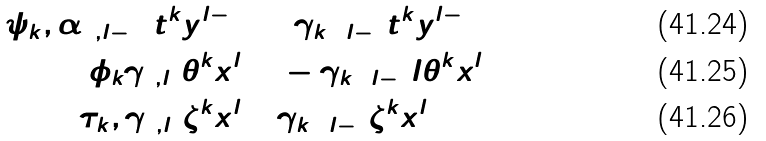Convert formula to latex. <formula><loc_0><loc_0><loc_500><loc_500>[ \psi _ { k } , \alpha _ { 0 , l - 1 } ] t ^ { k } y ^ { l - 1 } = & 2 \gamma _ { k + l - 1 } t ^ { k } y ^ { l - 1 } \\ [ \phi _ { k } \gamma _ { 0 , l } ] \theta ^ { k } x ^ { l } = & - \gamma _ { k + l - 1 } l \theta ^ { k } x ^ { l } \\ [ \tau _ { k } , \gamma _ { 0 , l } ] \zeta ^ { k } x ^ { l } = & \gamma _ { k + l - 1 } \zeta ^ { k } x ^ { l }</formula> 